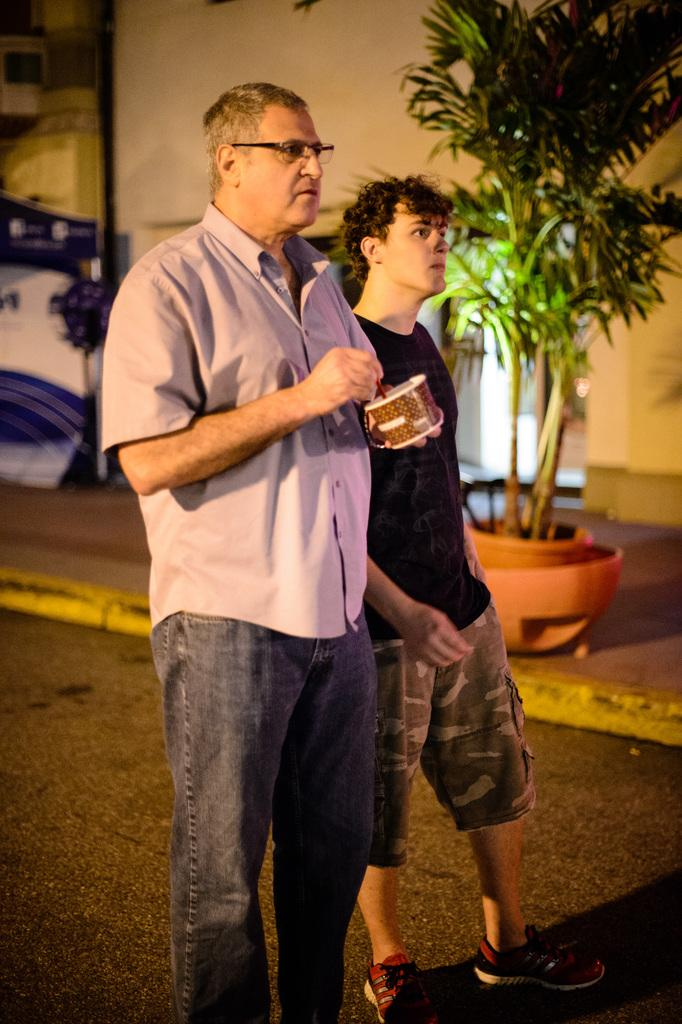How many people are in the image? There are two persons in the image. What is one of the persons holding? One of the persons is holding a cup and a spoon. What can be seen in the image besides the people? There is a plant and houses visible in the image. What type of weather can be seen in the image? There is no indication of weather in the image; it only shows two people, a plant, and houses. How many gold bikes are visible in the image? There are no bikes, gold or otherwise, present in the image. 